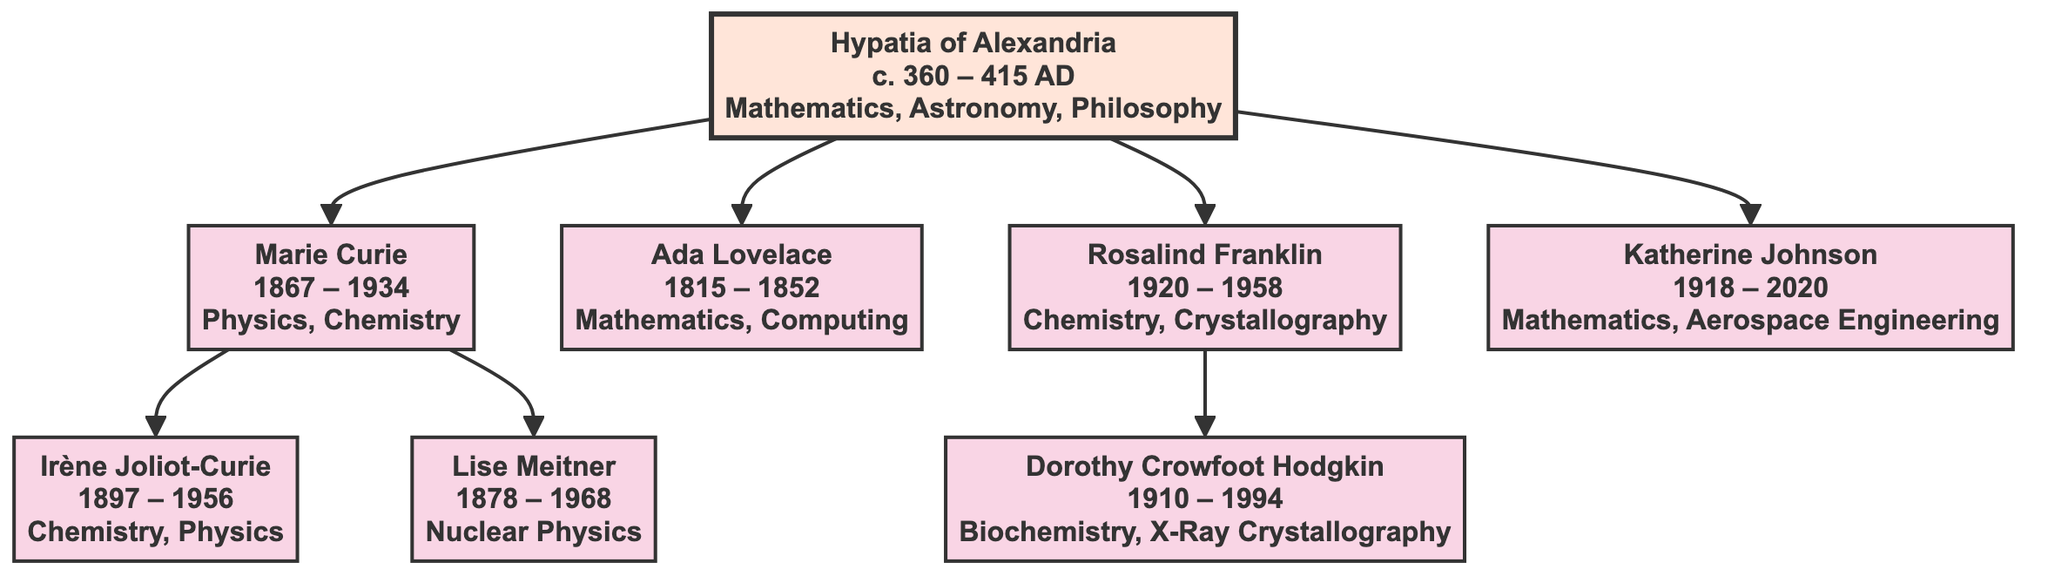What is the lifespan of Marie Curie? Marie Curie's lifespan is indicated in the diagram as "1867 – 1934." This specific information is provided directly within her node.
Answer: 1867 – 1934 Who are the children of Marie Curie? The diagram shows two nodes directly connected to Marie Curie, which are Irène Joliot-Curie and Lise Meitner. These nodes represent her children in the family tree.
Answer: Irène Joliot-Curie, Lise Meitner What field did Hypatia of Alexandria contribute to? Hypatia’s contributions are listed in her node, which explicitly mentions "Mathematics, Astronomy, Philosophy." Thus, her contributions are directly derived from the information presented.
Answer: Mathematics, Astronomy, Philosophy How many notable female scientists are directly descended from Hypatia? Counting the immediate connections from Hypatia’s node shows that there are four direct descendants: Marie Curie, Ada Lovelace, Rosalind Franklin, and Katherine Johnson. Therefore, the total count is four.
Answer: 4 Which scientist is recognized for the synthesis of new radioactive elements? The diagram lists Irène Joliot-Curie as a child of Marie Curie, and under her contributions, it states “Synthesis of New Radioactive Elements,” indicating that she is the relevant scientist.
Answer: Irène Joliot-Curie What discovery is Lise Meitner known for? According to the diagram, Lise Meitner’s notable work is explicitly stated as "Discovery of Nuclear Fission" in her node. This information allows us to directly identify her key achievement.
Answer: Discovery of Nuclear Fission Who did Rosalind Franklin's work influence? The diagram shows Rosalind Franklin’s child, Dorothy Crowfoot Hodgkin, who is linked to her. Since Hodgkin's node represents a descendant, it indicates a direct influence through her work in the field of chemistry and crystallography.
Answer: Dorothy Crowfoot Hodgkin What mathematical contribution did Ada Lovelace make? Ada Lovelace’s node contains the information "First Algorithm Intended for a Machine." This clear articulation within her node highlights her significant contribution to mathematics and computing.
Answer: First Algorithm Intended for a Machine Which field was Katherine Johnson primarily associated with? In the node representing Katherine Johnson, her contributions are indicated as "Mathematics, Aerospace Engineering." This information shows her specialized field of work, allowing us to classify her major contributions accurately.
Answer: Mathematics, Aerospace Engineering 